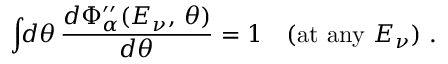<formula> <loc_0><loc_0><loc_500><loc_500>\int \, d \theta \, \frac { d \Phi _ { \alpha } ^ { \prime \prime } ( E _ { \nu } , \, \theta ) } { d \theta } = 1 \quad ( a t \ a n y \ E _ { \nu } ) \ .</formula> 